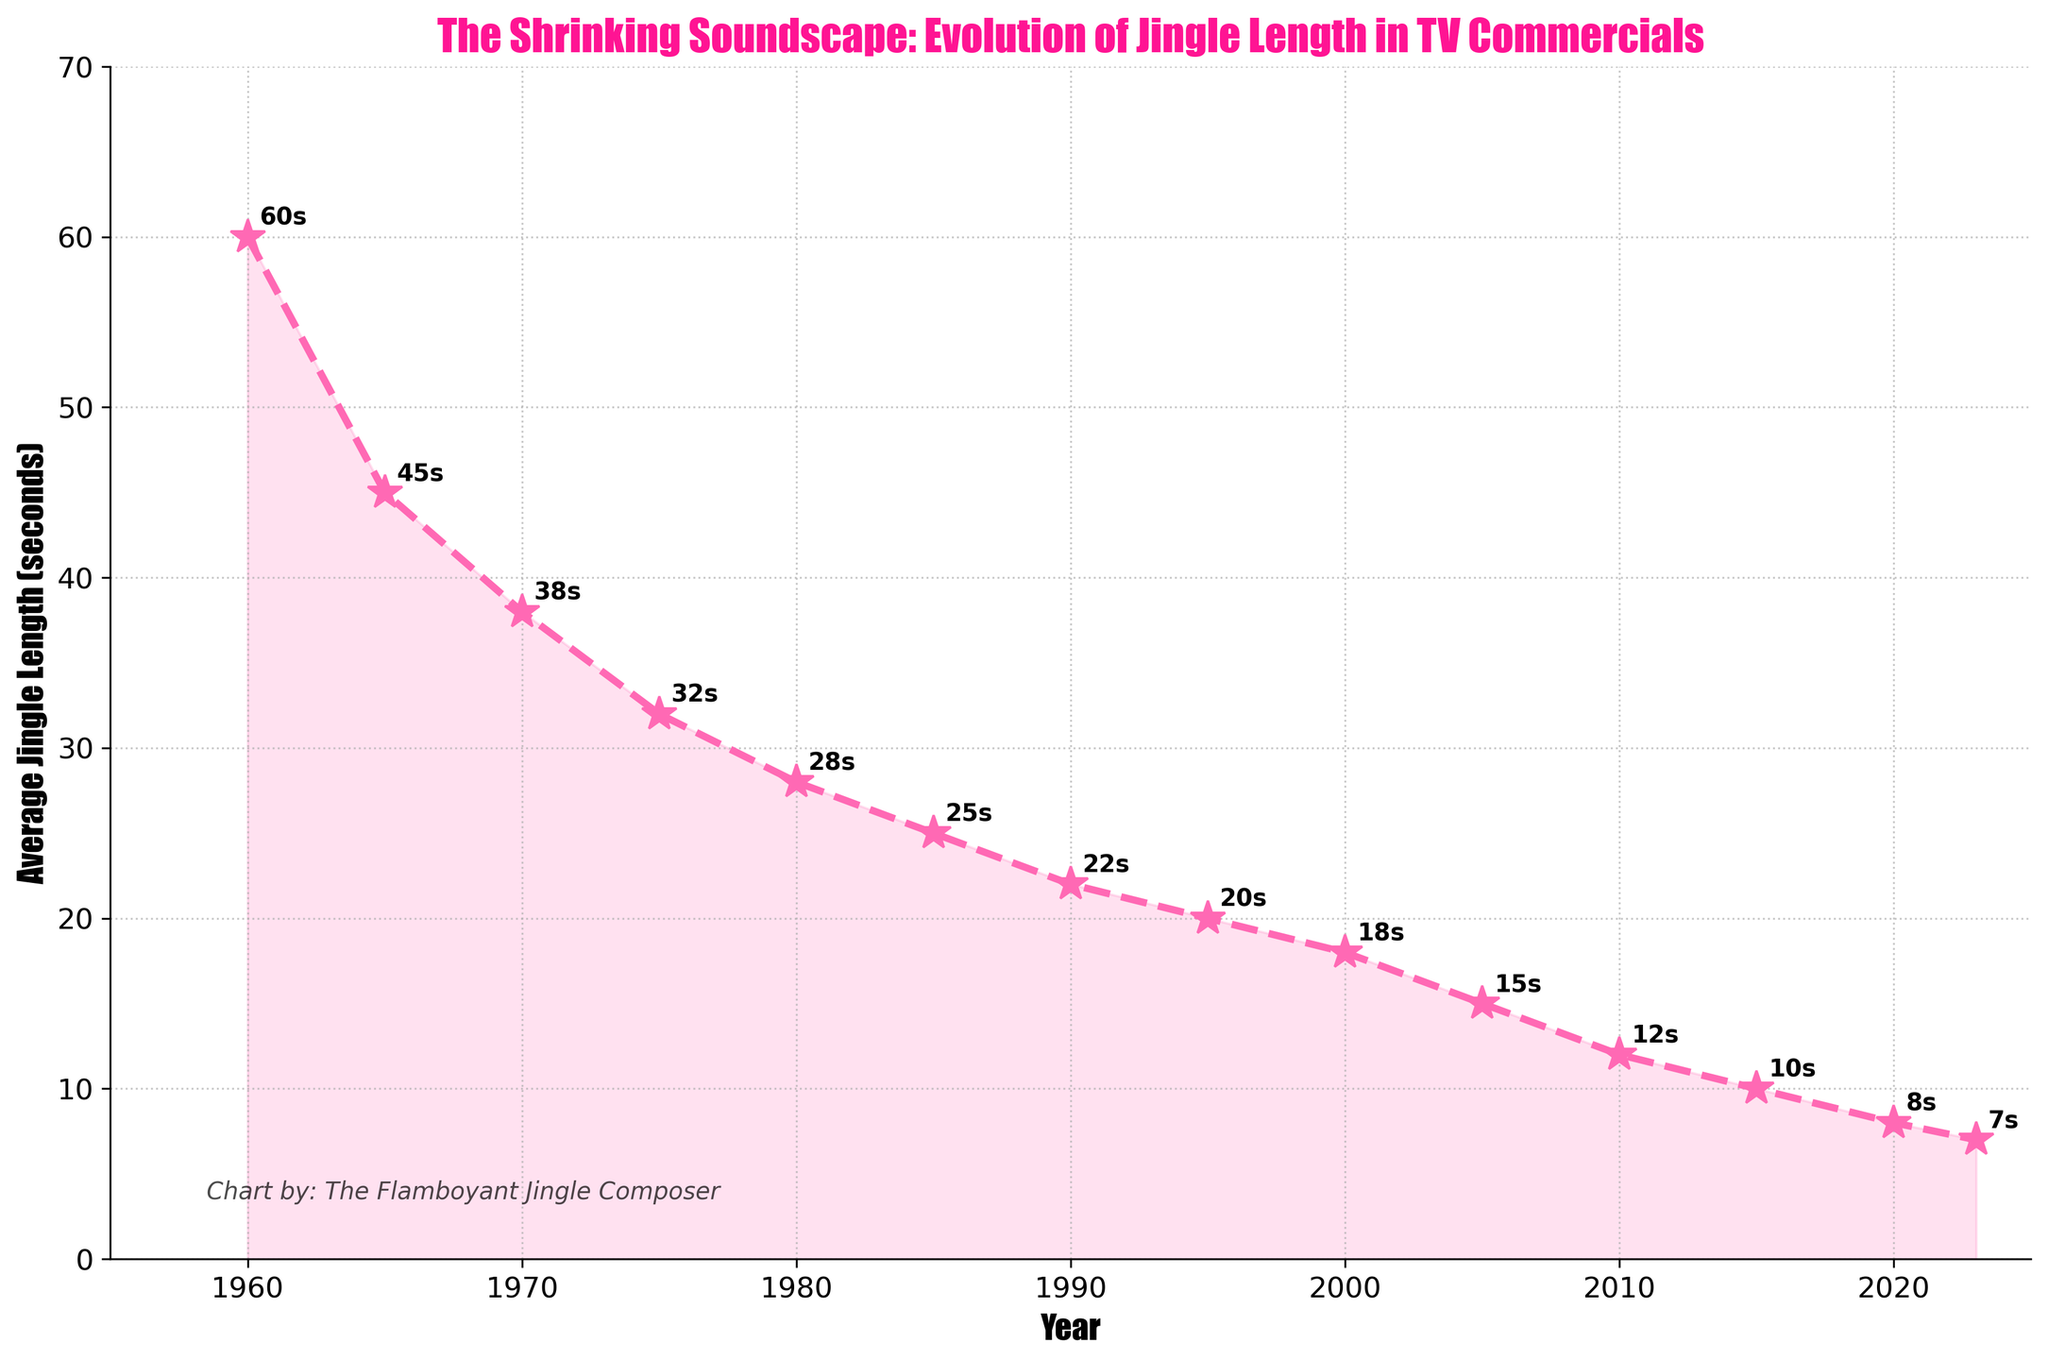What is the average jingle length in 1995? To find the average jingle length in 1995, look at the data point plotted for the year 1995. The value associated with this data point is the answer.
Answer: 20 seconds What was the approximate decrease in average jingle length from 1960 to 1980? Subtract the average jingle length in 1980 from the length in 1960: 60 seconds (1960) - 28 seconds (1980) = 32 seconds.
Answer: 32 seconds Between which consecutive years was the greatest decrease in average jingle length observed? Examine the differences between consecutive data points: The decrease from 1960 to 1965 is 15 seconds, from 1965 to 1970 is 7 seconds, and so on. The greatest difference is between 1960 and 1965.
Answer: 1960 to 1965 How does the average jingle length in 2023 compare to that in 1970? Observe the data points for both years. The length in 2023 is 7 seconds, and in 1970 it is 38 seconds. The length in 2023 is significantly shorter than in 1970.
Answer: 2023 is shorter What is the general trend of jingle length over time according to the chart? Observe the entire line plot: The line consistently descends as time progresses, indicating a general trend of decreasing average jingle length over the years.
Answer: Decreasing When did the average jingle length first drop below 20 seconds? Find the first data point where the value falls below 20 seconds. This happens in the year 1995, where the average length is exactly 20 seconds.
Answer: 1995 Calculate the average jingle length over the entire period from 1960 to 2023. Sum all the average jingle lengths from the provided years and divide by the number of years: (60 + 45 + 38 + 32 + 28 + 25 + 22 + 20 + 18 + 15 + 12 + 10 + 8 + 7) / 14 ≈ 24.1 seconds.
Answer: 24.1 seconds Does the jingle length decrease more quickly in earlier years (1960-1980) or later years (2000-2023)? Calculate the total decrease in the given periods: 1960-1980 is 60 - 28 = 32 seconds decrease. 2000-2023 is 18 - 7 = 11 seconds decrease. The earlier period shows a steeper decline.
Answer: Earlier years Which year marked the smallest change in jingle length in the 2010s? Look at the increments between each year within the 2010s: 2010-2015 shows a decrease by 2 seconds (from 12s to 10s), whereas 2015-2020 shows a decrease by 2 seconds (from 10s to 8s) and 2020-2023 sees a decrease of 1s (from 8s to 7s). 2020-2023 had the smallest change.
Answer: 2020-2023 How does the data visualization communicate the jingle length trend visually? The descending line plot with markers, the color fill under the curve, and the annotated values visually emphasize the steady decrease in average jingle length over the years.
Answer: Downward line plot with markers and annotations 